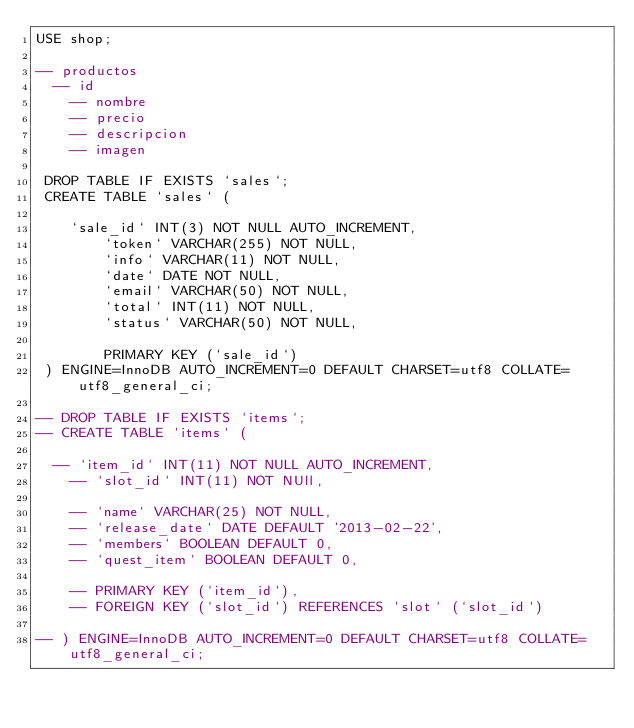Convert code to text. <code><loc_0><loc_0><loc_500><loc_500><_SQL_>USE shop;

-- productos
	-- id
    -- nombre
    -- precio
    -- descripcion
    -- imagen
 
 DROP TABLE IF EXISTS `sales`;
 CREATE TABLE `sales` (
 
		`sale_id` INT(3) NOT NULL AUTO_INCREMENT,
        `token` VARCHAR(255) NOT NULL,
        `info` VARCHAR(11) NOT NULL,
        `date` DATE NOT NULL,
        `email` VARCHAR(50) NOT NULL,
        `total` INT(11) NOT NULL,
        `status` VARCHAR(50) NOT NULL,
        
        PRIMARY KEY (`sale_id`)
 ) ENGINE=InnoDB AUTO_INCREMENT=0 DEFAULT CHARSET=utf8 COLLATE=utf8_general_ci;
    
-- DROP TABLE IF EXISTS `items`;
-- CREATE TABLE `items` (

	-- `item_id` INT(11) NOT NULL AUTO_INCREMENT,
    -- `slot_id` INT(11) NOT NUll,
    
    -- `name` VARCHAR(25) NOT NULL,
    -- `release_date` DATE DEFAULT '2013-02-22',
    -- `members` BOOLEAN DEFAULT 0,
    -- `quest_item` BOOLEAN DEFAULT 0,
    
    -- PRIMARY KEY (`item_id`),
    -- FOREIGN KEY (`slot_id`) REFERENCES `slot` (`slot_id`)
    
-- ) ENGINE=InnoDB AUTO_INCREMENT=0 DEFAULT CHARSET=utf8 COLLATE=utf8_general_ci;
</code> 